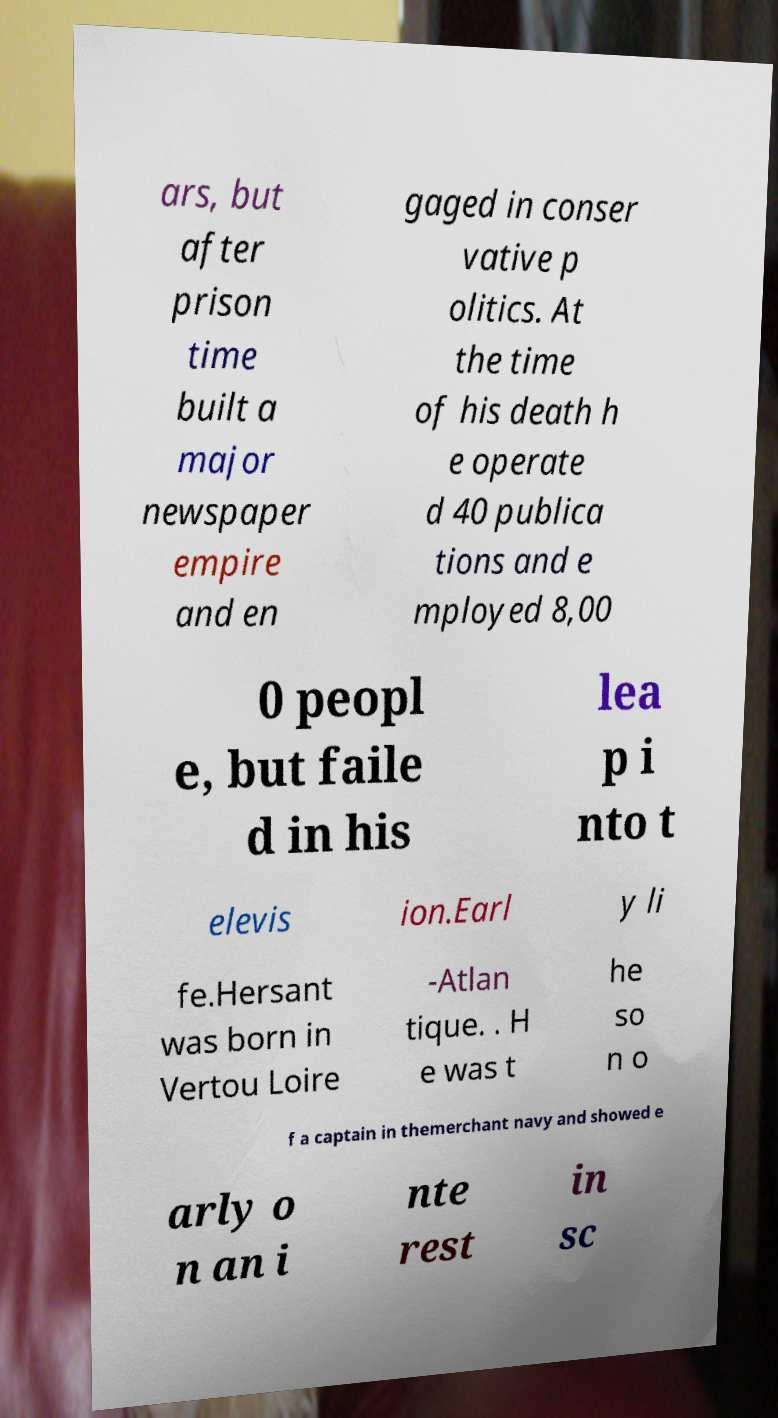What messages or text are displayed in this image? I need them in a readable, typed format. ars, but after prison time built a major newspaper empire and en gaged in conser vative p olitics. At the time of his death h e operate d 40 publica tions and e mployed 8,00 0 peopl e, but faile d in his lea p i nto t elevis ion.Earl y li fe.Hersant was born in Vertou Loire -Atlan tique. . H e was t he so n o f a captain in themerchant navy and showed e arly o n an i nte rest in sc 